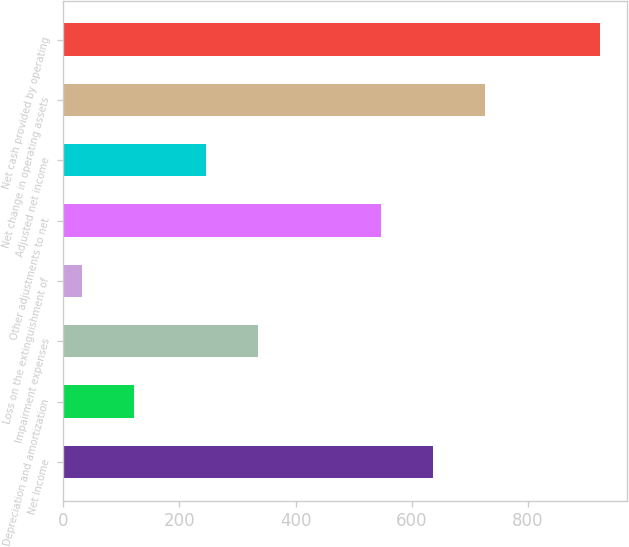<chart> <loc_0><loc_0><loc_500><loc_500><bar_chart><fcel>Net Income<fcel>Depreciation and amortization<fcel>Impairment expenses<fcel>Loss on the extinguishment of<fcel>Other adjustments to net<fcel>Adjusted net income<fcel>Net change in operating assets<fcel>Net cash provided by operating<nl><fcel>636.2<fcel>121.2<fcel>335.2<fcel>32<fcel>547<fcel>246<fcel>725.4<fcel>924<nl></chart> 